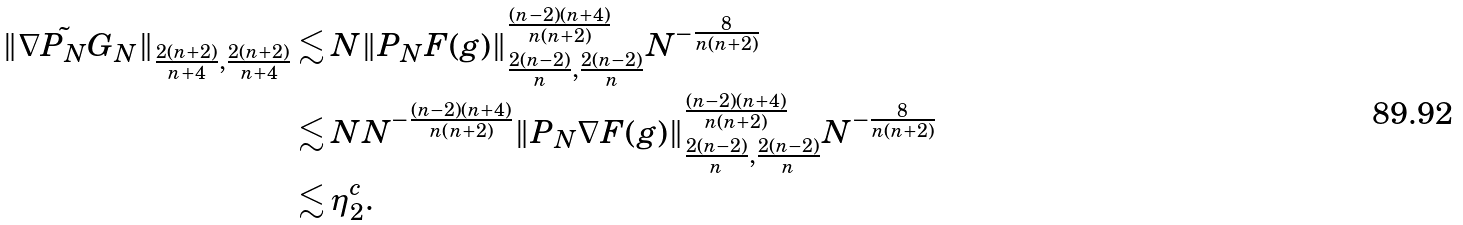<formula> <loc_0><loc_0><loc_500><loc_500>\| \nabla \tilde { P _ { N } } G _ { N } \| _ { \frac { 2 ( n + 2 ) } { n + 4 } , \frac { 2 ( n + 2 ) } { n + 4 } } & \lesssim N \| P _ { N } F ( g ) \| _ { \frac { 2 ( n - 2 ) } { n } , \frac { 2 ( n - 2 ) } { n } } ^ { \frac { ( n - 2 ) ( n + 4 ) } { n ( n + 2 ) } } N ^ { - \frac { 8 } { n ( n + 2 ) } } \\ & \lesssim N N ^ { - \frac { ( n - 2 ) ( n + 4 ) } { n ( n + 2 ) } } \| P _ { N } \nabla F ( g ) \| _ { \frac { 2 ( n - 2 ) } { n } , \frac { 2 ( n - 2 ) } { n } } ^ { \frac { ( n - 2 ) ( n + 4 ) } { n ( n + 2 ) } } N ^ { - \frac { 8 } { n ( n + 2 ) } } \\ & \lesssim \eta _ { 2 } ^ { c } .</formula> 